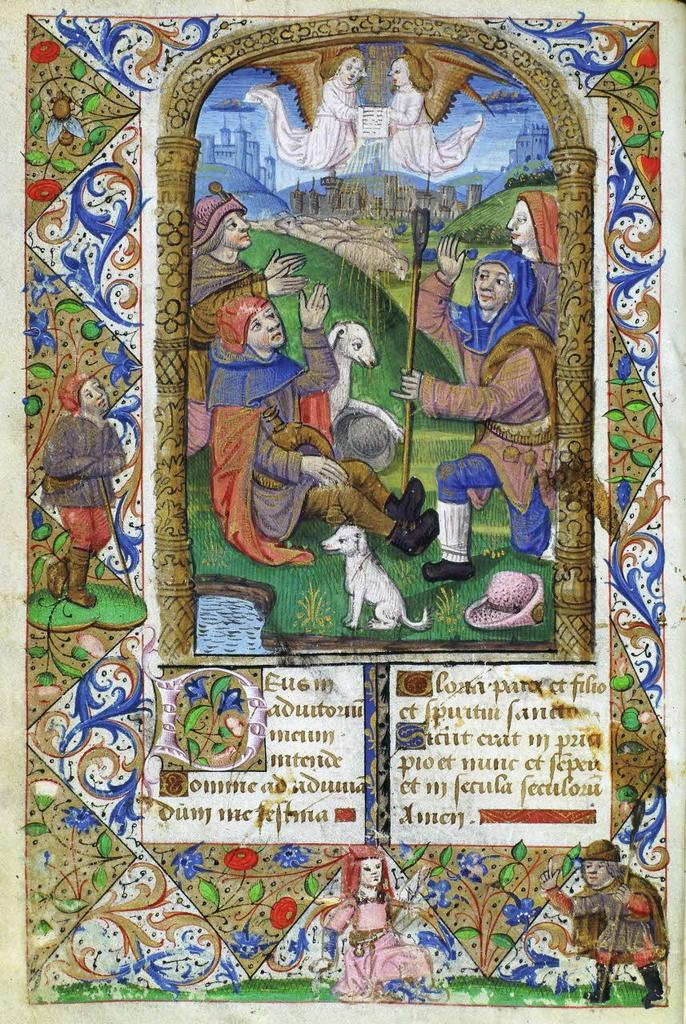What types of subjects can be seen in the image? There are persons, animals, and designs depicted in the image. What else is featured in the image besides the subjects? There is text present in the image. What type of drink is being consumed by the persons in the image? There is no drink present in the image; it only depicts persons, animals, designs, and text. What time of day is it in the image? The time of day is not depicted in the image. 